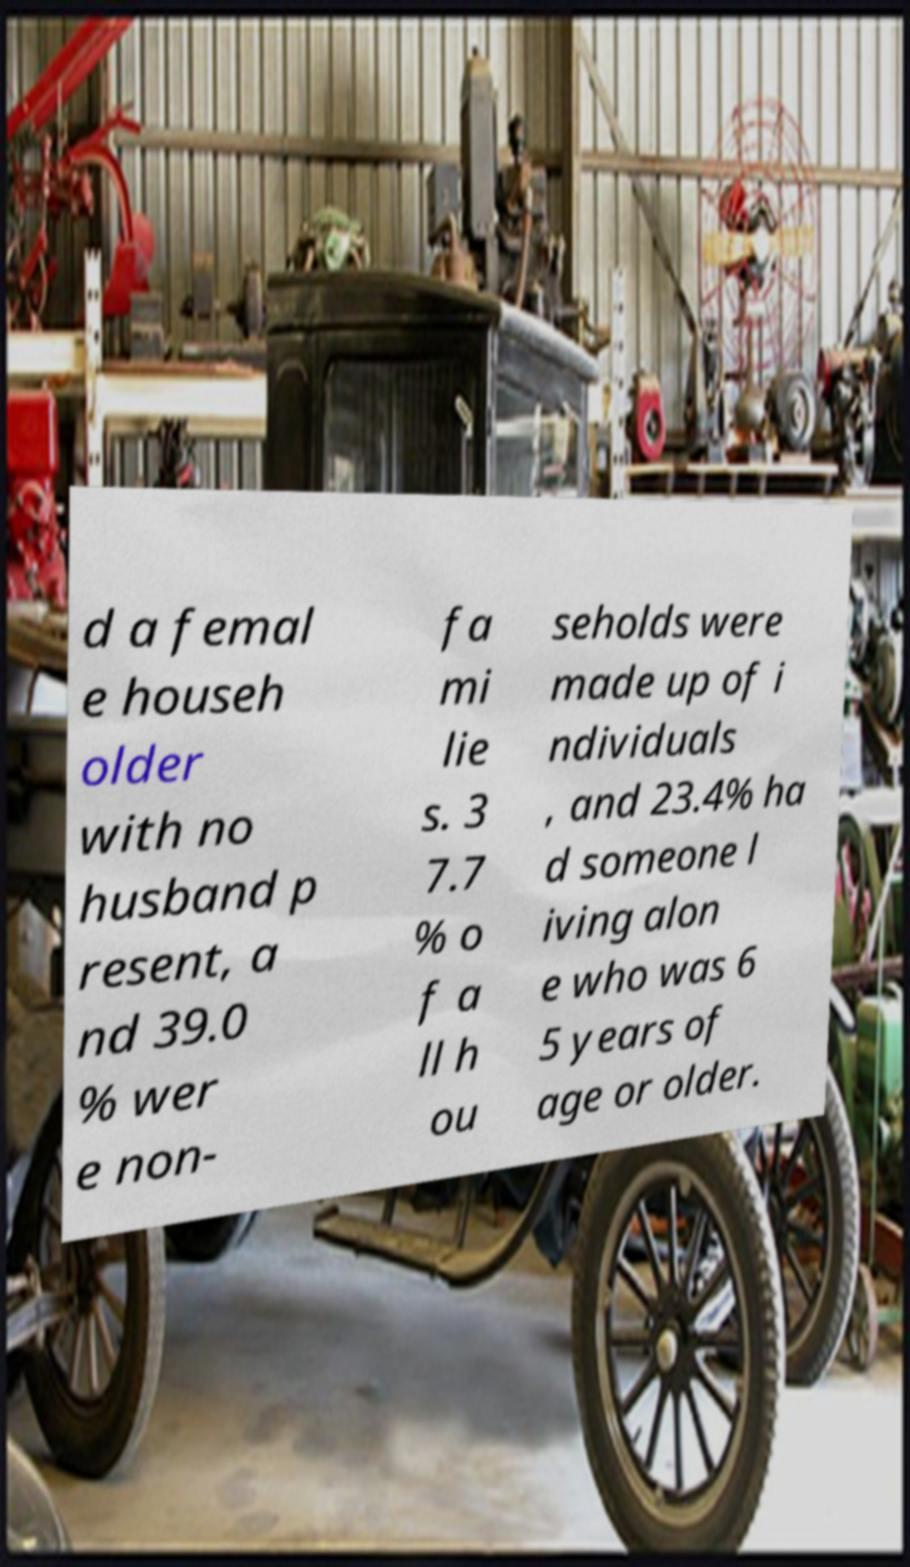Could you assist in decoding the text presented in this image and type it out clearly? d a femal e househ older with no husband p resent, a nd 39.0 % wer e non- fa mi lie s. 3 7.7 % o f a ll h ou seholds were made up of i ndividuals , and 23.4% ha d someone l iving alon e who was 6 5 years of age or older. 